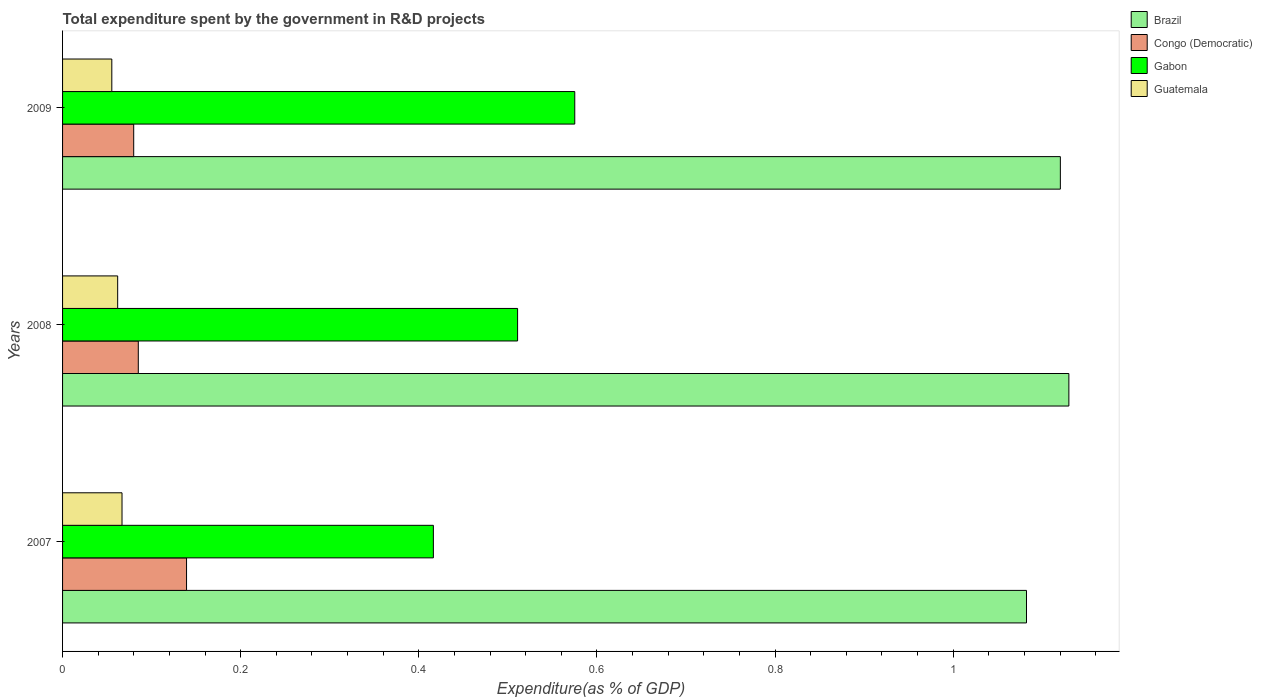How many different coloured bars are there?
Ensure brevity in your answer.  4. Are the number of bars per tick equal to the number of legend labels?
Keep it short and to the point. Yes. Are the number of bars on each tick of the Y-axis equal?
Your response must be concise. Yes. How many bars are there on the 3rd tick from the top?
Make the answer very short. 4. What is the total expenditure spent by the government in R&D projects in Brazil in 2008?
Your response must be concise. 1.13. Across all years, what is the maximum total expenditure spent by the government in R&D projects in Brazil?
Provide a short and direct response. 1.13. Across all years, what is the minimum total expenditure spent by the government in R&D projects in Gabon?
Provide a succinct answer. 0.42. In which year was the total expenditure spent by the government in R&D projects in Gabon maximum?
Your answer should be very brief. 2009. In which year was the total expenditure spent by the government in R&D projects in Gabon minimum?
Offer a terse response. 2007. What is the total total expenditure spent by the government in R&D projects in Congo (Democratic) in the graph?
Your answer should be very brief. 0.3. What is the difference between the total expenditure spent by the government in R&D projects in Brazil in 2007 and that in 2008?
Your answer should be very brief. -0.05. What is the difference between the total expenditure spent by the government in R&D projects in Congo (Democratic) in 2009 and the total expenditure spent by the government in R&D projects in Gabon in 2008?
Offer a very short reply. -0.43. What is the average total expenditure spent by the government in R&D projects in Congo (Democratic) per year?
Provide a succinct answer. 0.1. In the year 2008, what is the difference between the total expenditure spent by the government in R&D projects in Gabon and total expenditure spent by the government in R&D projects in Guatemala?
Offer a very short reply. 0.45. What is the ratio of the total expenditure spent by the government in R&D projects in Gabon in 2007 to that in 2009?
Keep it short and to the point. 0.72. Is the total expenditure spent by the government in R&D projects in Gabon in 2007 less than that in 2009?
Provide a succinct answer. Yes. Is the difference between the total expenditure spent by the government in R&D projects in Gabon in 2007 and 2008 greater than the difference between the total expenditure spent by the government in R&D projects in Guatemala in 2007 and 2008?
Your answer should be compact. No. What is the difference between the highest and the second highest total expenditure spent by the government in R&D projects in Gabon?
Offer a very short reply. 0.06. What is the difference between the highest and the lowest total expenditure spent by the government in R&D projects in Guatemala?
Make the answer very short. 0.01. Is the sum of the total expenditure spent by the government in R&D projects in Brazil in 2008 and 2009 greater than the maximum total expenditure spent by the government in R&D projects in Gabon across all years?
Offer a very short reply. Yes. What does the 3rd bar from the top in 2008 represents?
Provide a short and direct response. Congo (Democratic). What does the 4th bar from the bottom in 2007 represents?
Make the answer very short. Guatemala. Is it the case that in every year, the sum of the total expenditure spent by the government in R&D projects in Congo (Democratic) and total expenditure spent by the government in R&D projects in Guatemala is greater than the total expenditure spent by the government in R&D projects in Gabon?
Give a very brief answer. No. Are all the bars in the graph horizontal?
Keep it short and to the point. Yes. Does the graph contain any zero values?
Your response must be concise. No. How many legend labels are there?
Give a very brief answer. 4. What is the title of the graph?
Your answer should be compact. Total expenditure spent by the government in R&D projects. What is the label or title of the X-axis?
Make the answer very short. Expenditure(as % of GDP). What is the Expenditure(as % of GDP) of Brazil in 2007?
Provide a short and direct response. 1.08. What is the Expenditure(as % of GDP) of Congo (Democratic) in 2007?
Your answer should be compact. 0.14. What is the Expenditure(as % of GDP) in Gabon in 2007?
Your answer should be compact. 0.42. What is the Expenditure(as % of GDP) in Guatemala in 2007?
Provide a short and direct response. 0.07. What is the Expenditure(as % of GDP) in Brazil in 2008?
Make the answer very short. 1.13. What is the Expenditure(as % of GDP) of Congo (Democratic) in 2008?
Your response must be concise. 0.09. What is the Expenditure(as % of GDP) in Gabon in 2008?
Provide a succinct answer. 0.51. What is the Expenditure(as % of GDP) in Guatemala in 2008?
Keep it short and to the point. 0.06. What is the Expenditure(as % of GDP) of Brazil in 2009?
Provide a succinct answer. 1.12. What is the Expenditure(as % of GDP) of Congo (Democratic) in 2009?
Your response must be concise. 0.08. What is the Expenditure(as % of GDP) in Gabon in 2009?
Your response must be concise. 0.58. What is the Expenditure(as % of GDP) in Guatemala in 2009?
Provide a short and direct response. 0.06. Across all years, what is the maximum Expenditure(as % of GDP) in Brazil?
Give a very brief answer. 1.13. Across all years, what is the maximum Expenditure(as % of GDP) of Congo (Democratic)?
Give a very brief answer. 0.14. Across all years, what is the maximum Expenditure(as % of GDP) of Gabon?
Your answer should be compact. 0.58. Across all years, what is the maximum Expenditure(as % of GDP) of Guatemala?
Provide a short and direct response. 0.07. Across all years, what is the minimum Expenditure(as % of GDP) in Brazil?
Ensure brevity in your answer.  1.08. Across all years, what is the minimum Expenditure(as % of GDP) in Congo (Democratic)?
Your answer should be compact. 0.08. Across all years, what is the minimum Expenditure(as % of GDP) in Gabon?
Ensure brevity in your answer.  0.42. Across all years, what is the minimum Expenditure(as % of GDP) in Guatemala?
Make the answer very short. 0.06. What is the total Expenditure(as % of GDP) of Brazil in the graph?
Give a very brief answer. 3.33. What is the total Expenditure(as % of GDP) in Congo (Democratic) in the graph?
Provide a succinct answer. 0.3. What is the total Expenditure(as % of GDP) of Gabon in the graph?
Offer a terse response. 1.5. What is the total Expenditure(as % of GDP) of Guatemala in the graph?
Give a very brief answer. 0.18. What is the difference between the Expenditure(as % of GDP) in Brazil in 2007 and that in 2008?
Give a very brief answer. -0.05. What is the difference between the Expenditure(as % of GDP) of Congo (Democratic) in 2007 and that in 2008?
Offer a very short reply. 0.05. What is the difference between the Expenditure(as % of GDP) of Gabon in 2007 and that in 2008?
Your response must be concise. -0.09. What is the difference between the Expenditure(as % of GDP) of Guatemala in 2007 and that in 2008?
Your answer should be very brief. 0. What is the difference between the Expenditure(as % of GDP) of Brazil in 2007 and that in 2009?
Give a very brief answer. -0.04. What is the difference between the Expenditure(as % of GDP) in Congo (Democratic) in 2007 and that in 2009?
Keep it short and to the point. 0.06. What is the difference between the Expenditure(as % of GDP) of Gabon in 2007 and that in 2009?
Provide a succinct answer. -0.16. What is the difference between the Expenditure(as % of GDP) in Guatemala in 2007 and that in 2009?
Offer a terse response. 0.01. What is the difference between the Expenditure(as % of GDP) of Brazil in 2008 and that in 2009?
Provide a short and direct response. 0.01. What is the difference between the Expenditure(as % of GDP) of Congo (Democratic) in 2008 and that in 2009?
Keep it short and to the point. 0.01. What is the difference between the Expenditure(as % of GDP) of Gabon in 2008 and that in 2009?
Give a very brief answer. -0.06. What is the difference between the Expenditure(as % of GDP) in Guatemala in 2008 and that in 2009?
Keep it short and to the point. 0.01. What is the difference between the Expenditure(as % of GDP) of Brazil in 2007 and the Expenditure(as % of GDP) of Congo (Democratic) in 2008?
Your answer should be compact. 1. What is the difference between the Expenditure(as % of GDP) in Brazil in 2007 and the Expenditure(as % of GDP) in Guatemala in 2008?
Your answer should be very brief. 1.02. What is the difference between the Expenditure(as % of GDP) in Congo (Democratic) in 2007 and the Expenditure(as % of GDP) in Gabon in 2008?
Keep it short and to the point. -0.37. What is the difference between the Expenditure(as % of GDP) in Congo (Democratic) in 2007 and the Expenditure(as % of GDP) in Guatemala in 2008?
Your answer should be compact. 0.08. What is the difference between the Expenditure(as % of GDP) of Gabon in 2007 and the Expenditure(as % of GDP) of Guatemala in 2008?
Make the answer very short. 0.35. What is the difference between the Expenditure(as % of GDP) of Brazil in 2007 and the Expenditure(as % of GDP) of Gabon in 2009?
Offer a very short reply. 0.51. What is the difference between the Expenditure(as % of GDP) of Brazil in 2007 and the Expenditure(as % of GDP) of Guatemala in 2009?
Your answer should be very brief. 1.03. What is the difference between the Expenditure(as % of GDP) in Congo (Democratic) in 2007 and the Expenditure(as % of GDP) in Gabon in 2009?
Your answer should be compact. -0.44. What is the difference between the Expenditure(as % of GDP) of Congo (Democratic) in 2007 and the Expenditure(as % of GDP) of Guatemala in 2009?
Your answer should be very brief. 0.08. What is the difference between the Expenditure(as % of GDP) in Gabon in 2007 and the Expenditure(as % of GDP) in Guatemala in 2009?
Provide a short and direct response. 0.36. What is the difference between the Expenditure(as % of GDP) in Brazil in 2008 and the Expenditure(as % of GDP) in Congo (Democratic) in 2009?
Your answer should be compact. 1.05. What is the difference between the Expenditure(as % of GDP) in Brazil in 2008 and the Expenditure(as % of GDP) in Gabon in 2009?
Offer a very short reply. 0.55. What is the difference between the Expenditure(as % of GDP) in Brazil in 2008 and the Expenditure(as % of GDP) in Guatemala in 2009?
Offer a terse response. 1.07. What is the difference between the Expenditure(as % of GDP) in Congo (Democratic) in 2008 and the Expenditure(as % of GDP) in Gabon in 2009?
Your answer should be very brief. -0.49. What is the difference between the Expenditure(as % of GDP) of Congo (Democratic) in 2008 and the Expenditure(as % of GDP) of Guatemala in 2009?
Your response must be concise. 0.03. What is the difference between the Expenditure(as % of GDP) of Gabon in 2008 and the Expenditure(as % of GDP) of Guatemala in 2009?
Your answer should be compact. 0.46. What is the average Expenditure(as % of GDP) in Brazil per year?
Provide a short and direct response. 1.11. What is the average Expenditure(as % of GDP) in Congo (Democratic) per year?
Provide a short and direct response. 0.1. What is the average Expenditure(as % of GDP) of Gabon per year?
Give a very brief answer. 0.5. What is the average Expenditure(as % of GDP) of Guatemala per year?
Keep it short and to the point. 0.06. In the year 2007, what is the difference between the Expenditure(as % of GDP) in Brazil and Expenditure(as % of GDP) in Congo (Democratic)?
Offer a very short reply. 0.94. In the year 2007, what is the difference between the Expenditure(as % of GDP) in Brazil and Expenditure(as % of GDP) in Gabon?
Give a very brief answer. 0.67. In the year 2007, what is the difference between the Expenditure(as % of GDP) in Brazil and Expenditure(as % of GDP) in Guatemala?
Your answer should be compact. 1.02. In the year 2007, what is the difference between the Expenditure(as % of GDP) in Congo (Democratic) and Expenditure(as % of GDP) in Gabon?
Your answer should be compact. -0.28. In the year 2007, what is the difference between the Expenditure(as % of GDP) in Congo (Democratic) and Expenditure(as % of GDP) in Guatemala?
Your answer should be compact. 0.07. In the year 2007, what is the difference between the Expenditure(as % of GDP) of Gabon and Expenditure(as % of GDP) of Guatemala?
Provide a succinct answer. 0.35. In the year 2008, what is the difference between the Expenditure(as % of GDP) of Brazil and Expenditure(as % of GDP) of Congo (Democratic)?
Provide a succinct answer. 1.04. In the year 2008, what is the difference between the Expenditure(as % of GDP) of Brazil and Expenditure(as % of GDP) of Gabon?
Provide a succinct answer. 0.62. In the year 2008, what is the difference between the Expenditure(as % of GDP) in Brazil and Expenditure(as % of GDP) in Guatemala?
Give a very brief answer. 1.07. In the year 2008, what is the difference between the Expenditure(as % of GDP) of Congo (Democratic) and Expenditure(as % of GDP) of Gabon?
Give a very brief answer. -0.43. In the year 2008, what is the difference between the Expenditure(as % of GDP) of Congo (Democratic) and Expenditure(as % of GDP) of Guatemala?
Offer a very short reply. 0.02. In the year 2008, what is the difference between the Expenditure(as % of GDP) of Gabon and Expenditure(as % of GDP) of Guatemala?
Make the answer very short. 0.45. In the year 2009, what is the difference between the Expenditure(as % of GDP) in Brazil and Expenditure(as % of GDP) in Congo (Democratic)?
Make the answer very short. 1.04. In the year 2009, what is the difference between the Expenditure(as % of GDP) of Brazil and Expenditure(as % of GDP) of Gabon?
Give a very brief answer. 0.55. In the year 2009, what is the difference between the Expenditure(as % of GDP) in Brazil and Expenditure(as % of GDP) in Guatemala?
Provide a short and direct response. 1.06. In the year 2009, what is the difference between the Expenditure(as % of GDP) in Congo (Democratic) and Expenditure(as % of GDP) in Gabon?
Make the answer very short. -0.5. In the year 2009, what is the difference between the Expenditure(as % of GDP) of Congo (Democratic) and Expenditure(as % of GDP) of Guatemala?
Your response must be concise. 0.02. In the year 2009, what is the difference between the Expenditure(as % of GDP) of Gabon and Expenditure(as % of GDP) of Guatemala?
Your answer should be very brief. 0.52. What is the ratio of the Expenditure(as % of GDP) in Brazil in 2007 to that in 2008?
Make the answer very short. 0.96. What is the ratio of the Expenditure(as % of GDP) of Congo (Democratic) in 2007 to that in 2008?
Give a very brief answer. 1.64. What is the ratio of the Expenditure(as % of GDP) in Gabon in 2007 to that in 2008?
Your answer should be very brief. 0.81. What is the ratio of the Expenditure(as % of GDP) in Guatemala in 2007 to that in 2008?
Provide a succinct answer. 1.08. What is the ratio of the Expenditure(as % of GDP) of Brazil in 2007 to that in 2009?
Ensure brevity in your answer.  0.97. What is the ratio of the Expenditure(as % of GDP) of Congo (Democratic) in 2007 to that in 2009?
Make the answer very short. 1.74. What is the ratio of the Expenditure(as % of GDP) of Gabon in 2007 to that in 2009?
Your answer should be compact. 0.72. What is the ratio of the Expenditure(as % of GDP) of Guatemala in 2007 to that in 2009?
Ensure brevity in your answer.  1.21. What is the ratio of the Expenditure(as % of GDP) in Brazil in 2008 to that in 2009?
Keep it short and to the point. 1.01. What is the ratio of the Expenditure(as % of GDP) of Congo (Democratic) in 2008 to that in 2009?
Offer a very short reply. 1.06. What is the ratio of the Expenditure(as % of GDP) of Gabon in 2008 to that in 2009?
Keep it short and to the point. 0.89. What is the ratio of the Expenditure(as % of GDP) of Guatemala in 2008 to that in 2009?
Keep it short and to the point. 1.12. What is the difference between the highest and the second highest Expenditure(as % of GDP) of Brazil?
Your answer should be compact. 0.01. What is the difference between the highest and the second highest Expenditure(as % of GDP) in Congo (Democratic)?
Make the answer very short. 0.05. What is the difference between the highest and the second highest Expenditure(as % of GDP) of Gabon?
Your answer should be compact. 0.06. What is the difference between the highest and the second highest Expenditure(as % of GDP) in Guatemala?
Give a very brief answer. 0. What is the difference between the highest and the lowest Expenditure(as % of GDP) in Brazil?
Your answer should be compact. 0.05. What is the difference between the highest and the lowest Expenditure(as % of GDP) of Congo (Democratic)?
Provide a short and direct response. 0.06. What is the difference between the highest and the lowest Expenditure(as % of GDP) in Gabon?
Ensure brevity in your answer.  0.16. What is the difference between the highest and the lowest Expenditure(as % of GDP) of Guatemala?
Provide a short and direct response. 0.01. 